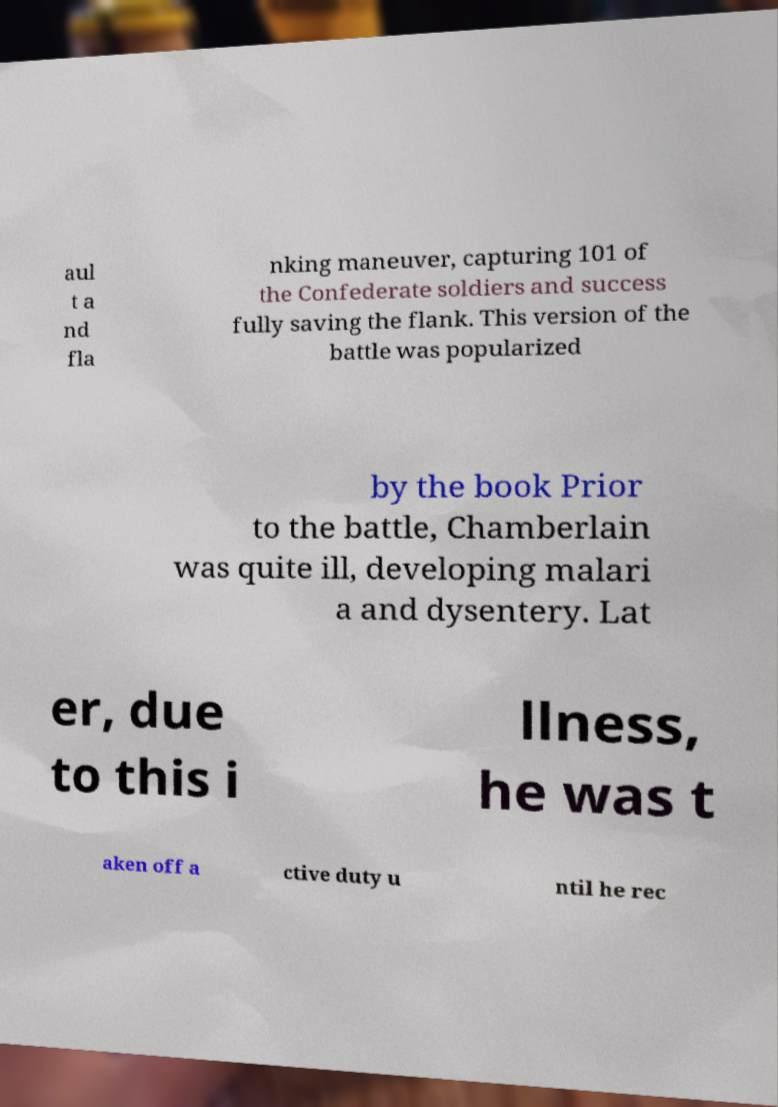What messages or text are displayed in this image? I need them in a readable, typed format. aul t a nd fla nking maneuver, capturing 101 of the Confederate soldiers and success fully saving the flank. This version of the battle was popularized by the book Prior to the battle, Chamberlain was quite ill, developing malari a and dysentery. Lat er, due to this i llness, he was t aken off a ctive duty u ntil he rec 